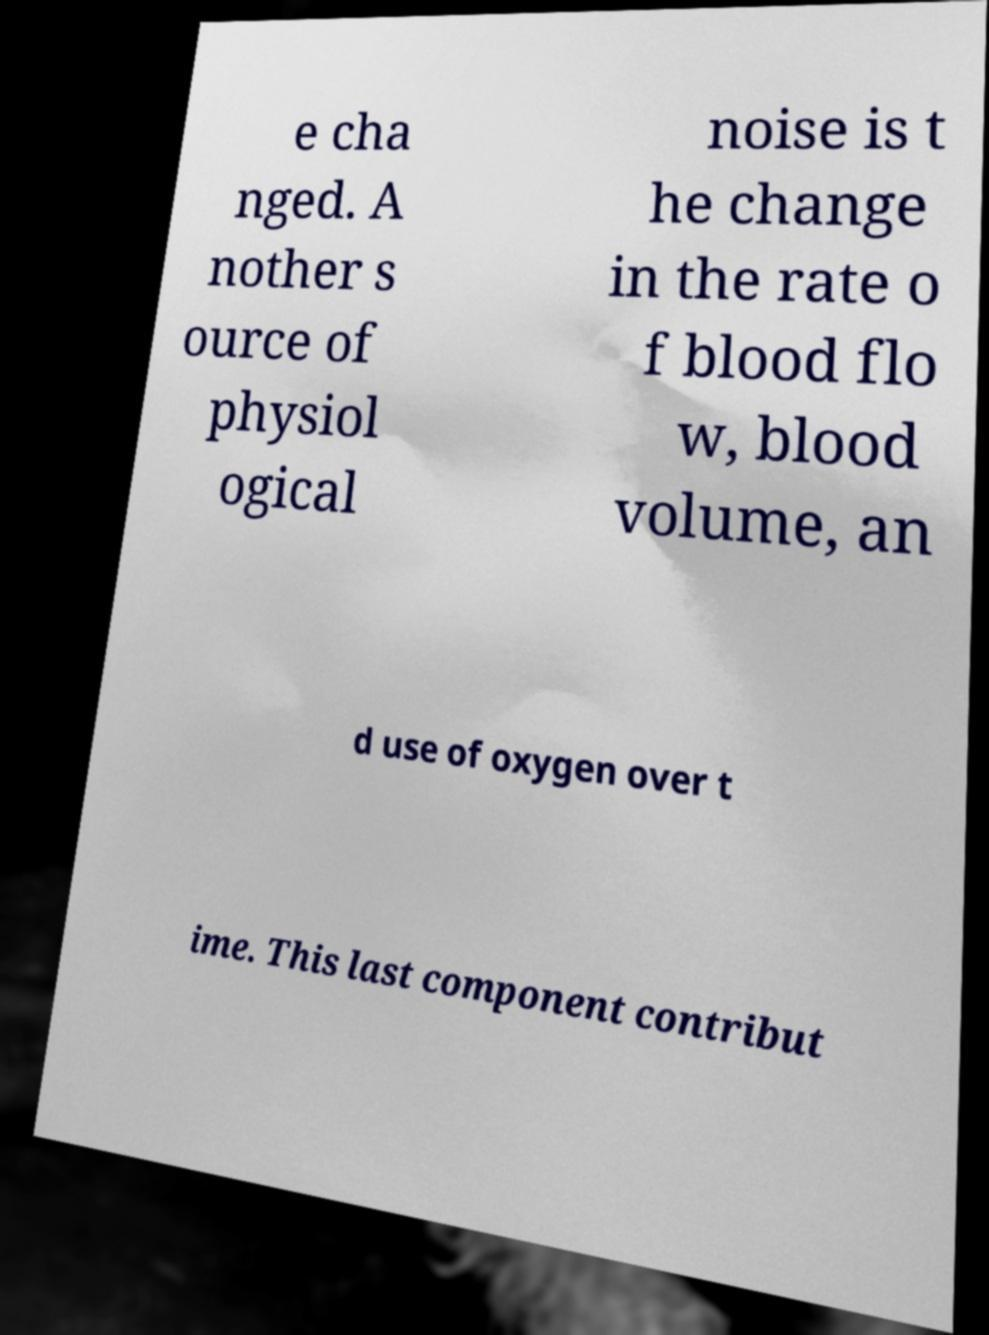What messages or text are displayed in this image? I need them in a readable, typed format. e cha nged. A nother s ource of physiol ogical noise is t he change in the rate o f blood flo w, blood volume, an d use of oxygen over t ime. This last component contribut 